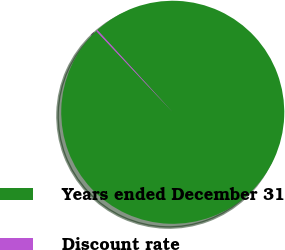Convert chart. <chart><loc_0><loc_0><loc_500><loc_500><pie_chart><fcel>Years ended December 31<fcel>Discount rate<nl><fcel>99.79%<fcel>0.21%<nl></chart> 